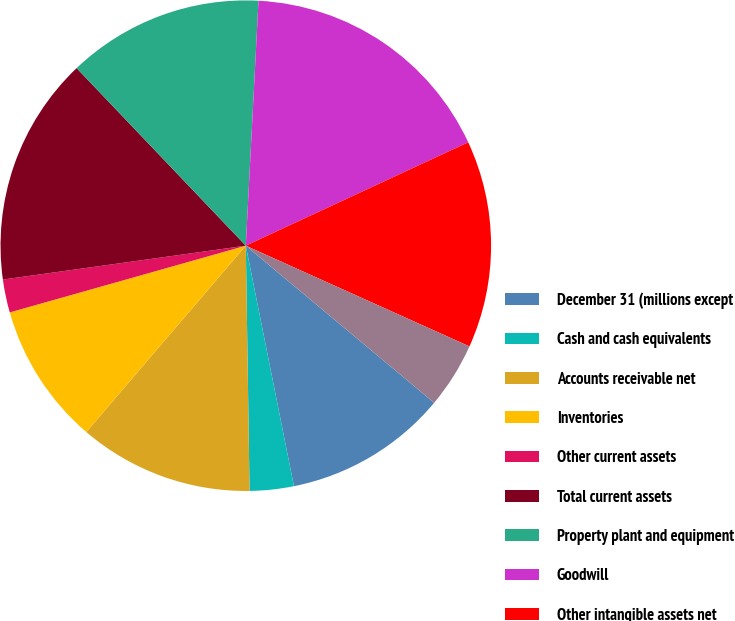Convert chart to OTSL. <chart><loc_0><loc_0><loc_500><loc_500><pie_chart><fcel>December 31 (millions except<fcel>Cash and cash equivalents<fcel>Accounts receivable net<fcel>Inventories<fcel>Other current assets<fcel>Total current assets<fcel>Property plant and equipment<fcel>Goodwill<fcel>Other intangible assets net<fcel>Other assets<nl><fcel>10.79%<fcel>2.9%<fcel>11.51%<fcel>9.35%<fcel>2.18%<fcel>15.09%<fcel>12.94%<fcel>17.25%<fcel>13.66%<fcel>4.33%<nl></chart> 